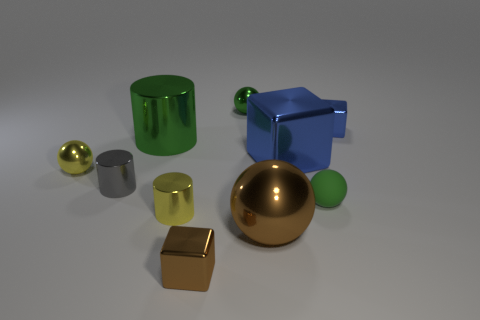Subtract all cyan cylinders. How many green balls are left? 2 Subtract all blue shiny cubes. How many cubes are left? 1 Subtract 1 balls. How many balls are left? 3 Subtract all purple balls. Subtract all cyan cubes. How many balls are left? 4 Subtract all spheres. How many objects are left? 6 Subtract all big green cylinders. Subtract all tiny gray shiny cylinders. How many objects are left? 8 Add 5 metal blocks. How many metal blocks are left? 8 Add 3 small blue things. How many small blue things exist? 4 Subtract 0 purple cylinders. How many objects are left? 10 